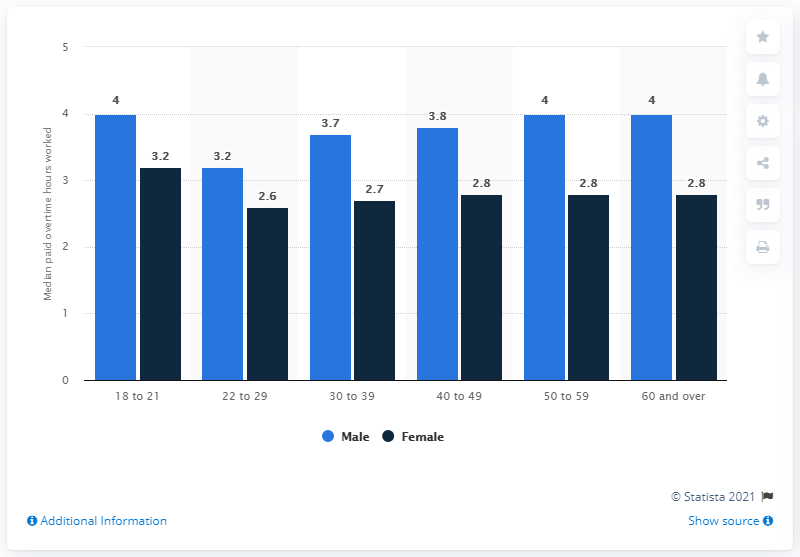Draw attention to some important aspects in this diagram. There are 6 categories of age in the graph. There are three categories of age where the median paid is the same for males. 